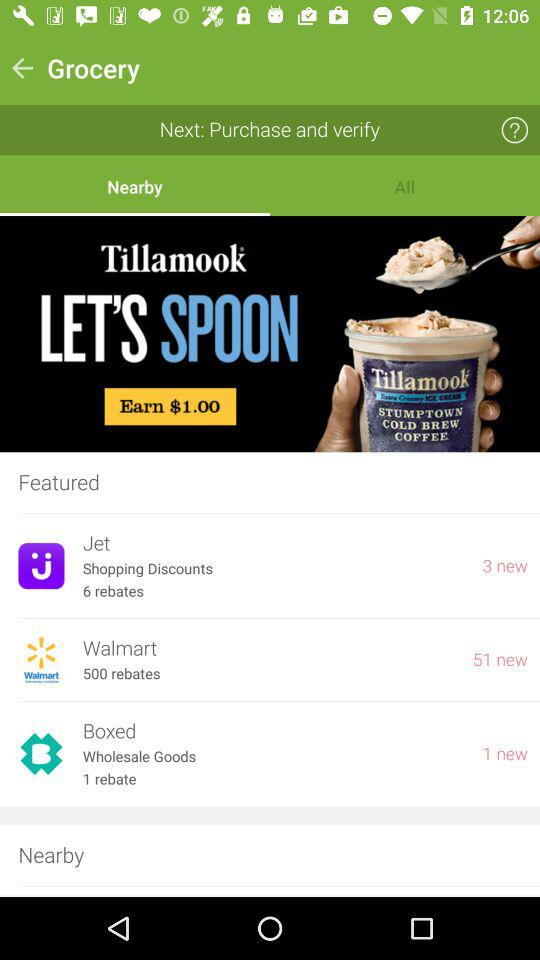How many new items are there for Boxed?
Answer the question using a single word or phrase. 1 